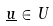<formula> <loc_0><loc_0><loc_500><loc_500>\underline { u } \in U</formula> 